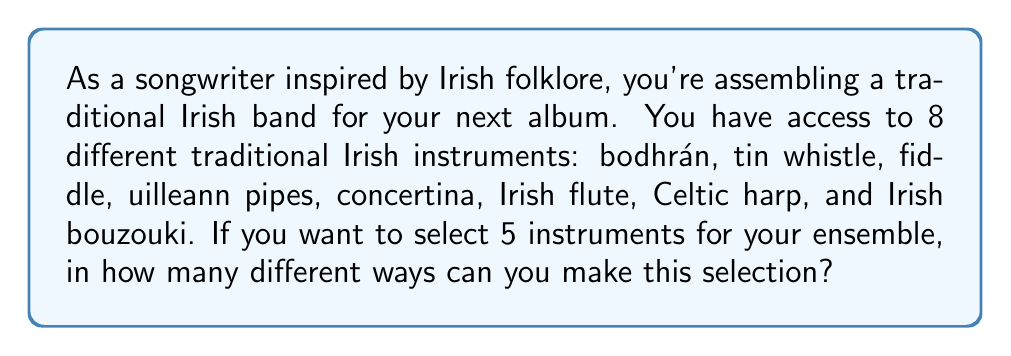Can you solve this math problem? To solve this problem, we need to use the combination formula. This is because:
1. The order of selection doesn't matter (selecting a bodhrán first and then a fiddle is the same as selecting a fiddle first and then a bodhrán).
2. We are selecting a subset of instruments from the total available.

The combination formula is:

$${n \choose k} = \frac{n!}{k!(n-k)!}$$

Where:
$n$ is the total number of items to choose from (in this case, 8 instruments)
$k$ is the number of items being chosen (in this case, 5 instruments)

Let's plug in our values:

$${8 \choose 5} = \frac{8!}{5!(8-5)!} = \frac{8!}{5!(3)!}$$

Now, let's calculate this step by step:

1) $8! = 8 \times 7 \times 6 \times 5 \times 4 \times 3 \times 2 \times 1 = 40,320$
2) $5! = 5 \times 4 \times 3 \times 2 \times 1 = 120$
3) $3! = 3 \times 2 \times 1 = 6$

Substituting these values:

$$\frac{40,320}{120 \times 6} = \frac{40,320}{720} = 56$$

Therefore, there are 56 different ways to select 5 instruments from the 8 available traditional Irish instruments.
Answer: 56 